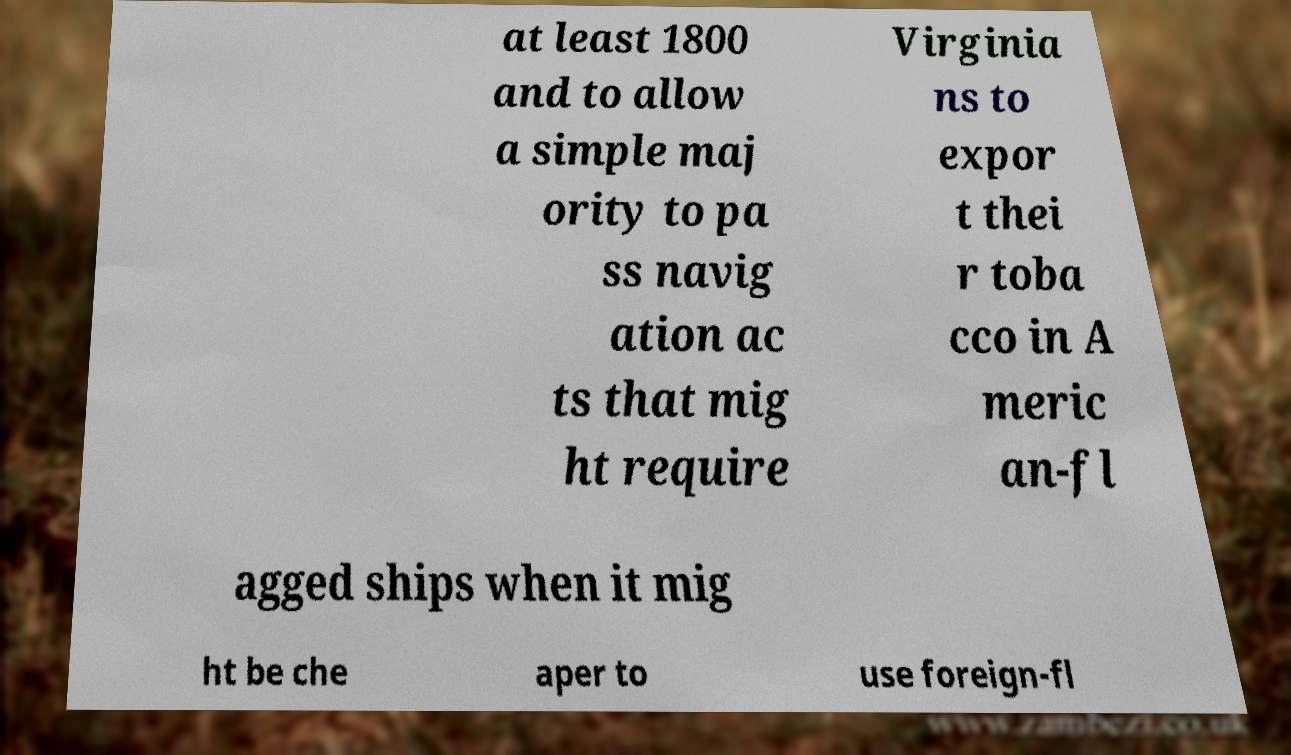Can you read and provide the text displayed in the image?This photo seems to have some interesting text. Can you extract and type it out for me? at least 1800 and to allow a simple maj ority to pa ss navig ation ac ts that mig ht require Virginia ns to expor t thei r toba cco in A meric an-fl agged ships when it mig ht be che aper to use foreign-fl 